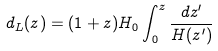<formula> <loc_0><loc_0><loc_500><loc_500>d _ { L } ( z ) = ( 1 + z ) H _ { 0 } \int _ { 0 } ^ { z } \frac { d z ^ { \prime } } { H ( z ^ { \prime } ) }</formula> 